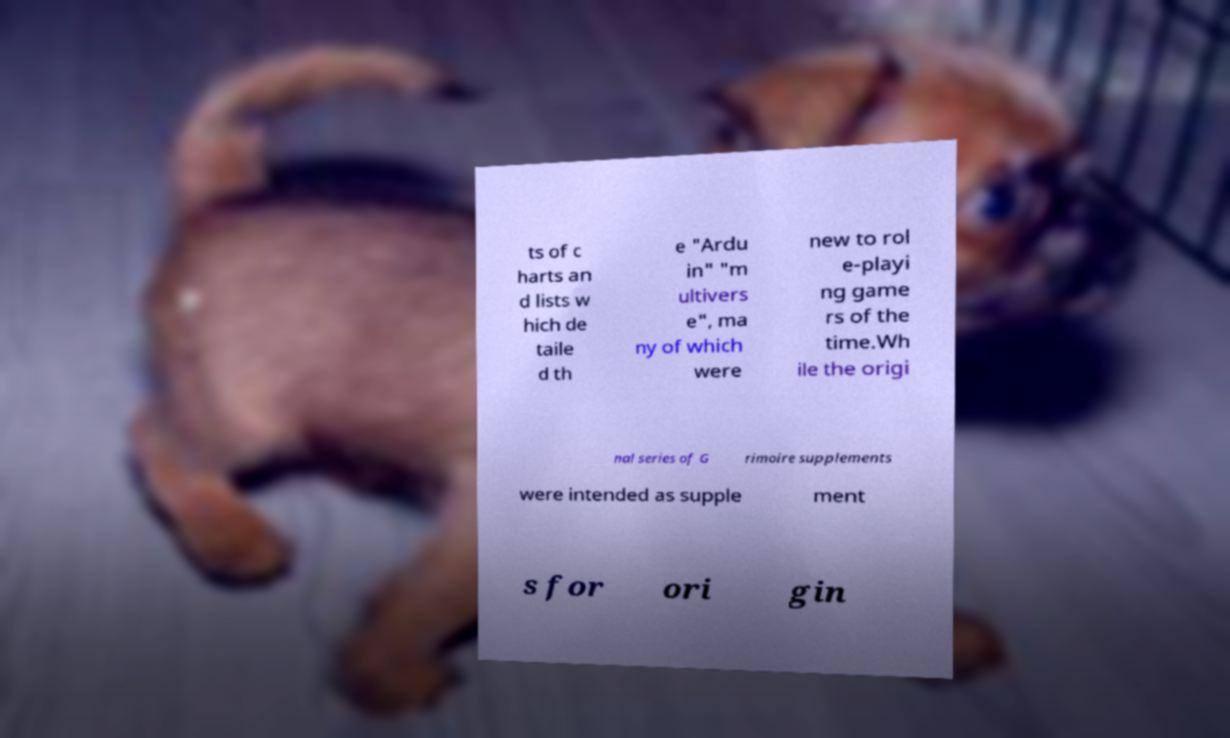Please identify and transcribe the text found in this image. ts of c harts an d lists w hich de taile d th e "Ardu in" "m ultivers e", ma ny of which were new to rol e-playi ng game rs of the time.Wh ile the origi nal series of G rimoire supplements were intended as supple ment s for ori gin 